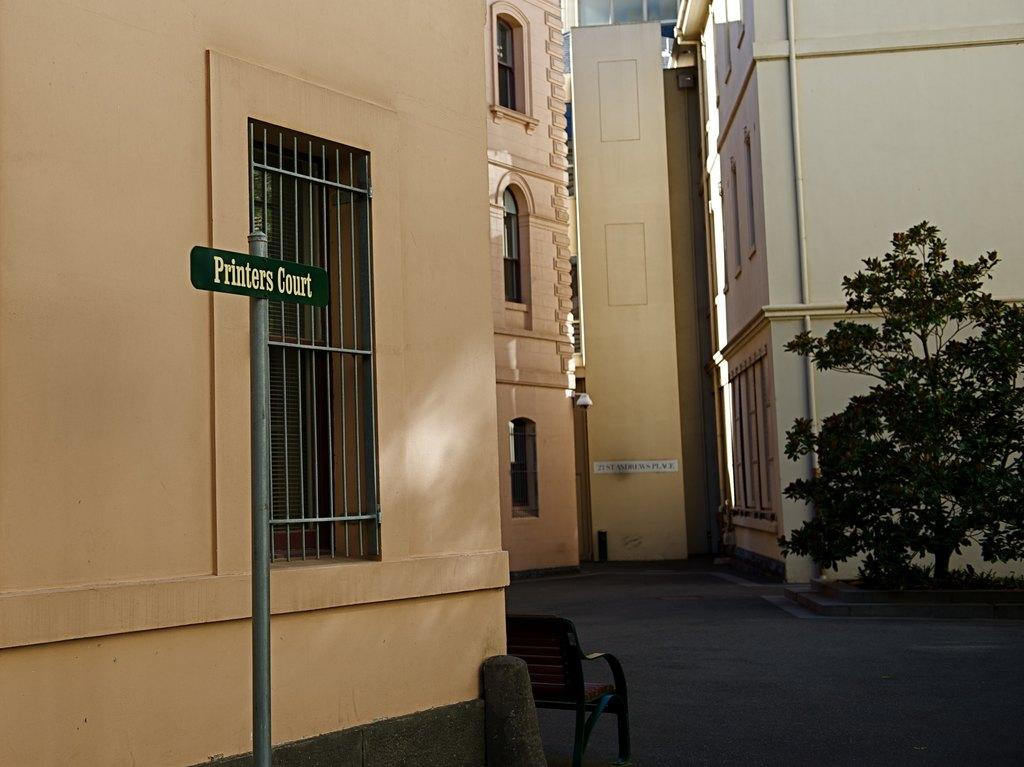What type of structures are visible in the image? There are many buildings with windows in the image. Can you describe any other objects near the buildings? There is a bench near the building. What is attached to the pole in the image? There is a pole with a name board in the image. What type of vegetation is present in the image? There is a tree in the image. What type of curtain is hanging from the wall in the image? There is no curtain present in the image. How many visitors can be seen in the image? There is no visitor present in the image. 